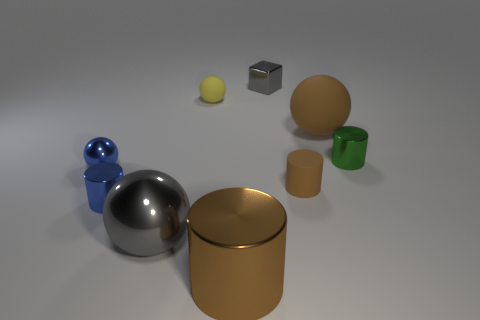Subtract 1 cylinders. How many cylinders are left? 3 Subtract all cylinders. How many objects are left? 5 Subtract all small blue things. Subtract all small green shiny cylinders. How many objects are left? 6 Add 2 big gray metal things. How many big gray metal things are left? 3 Add 4 small red metallic cylinders. How many small red metallic cylinders exist? 4 Subtract 0 blue cubes. How many objects are left? 9 